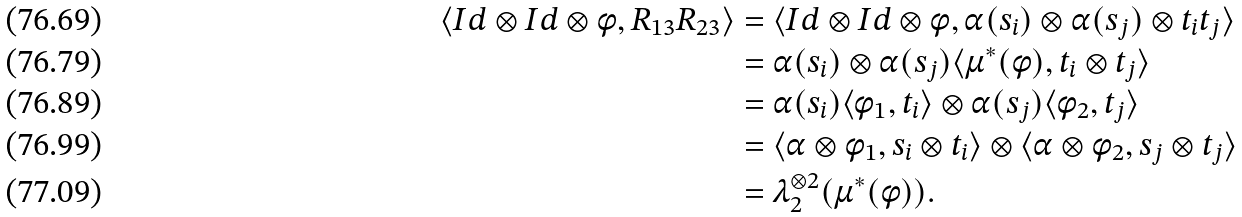<formula> <loc_0><loc_0><loc_500><loc_500>\langle I d \otimes I d \otimes \phi , R _ { 1 3 } R _ { 2 3 } \rangle & = \langle I d \otimes I d \otimes \phi , \alpha ( s _ { i } ) \otimes \alpha ( s _ { j } ) \otimes t _ { i } t _ { j } \rangle \\ & = \alpha ( s _ { i } ) \otimes \alpha ( s _ { j } ) \langle \mu ^ { * } ( \phi ) , t _ { i } \otimes t _ { j } \rangle \\ & = \alpha ( s _ { i } ) \langle \phi _ { 1 } , t _ { i } \rangle \otimes \alpha ( s _ { j } ) \langle \phi _ { 2 } , t _ { j } \rangle \\ & = \langle \alpha \otimes \phi _ { 1 } , s _ { i } \otimes t _ { i } \rangle \otimes \langle \alpha \otimes \phi _ { 2 } , s _ { j } \otimes t _ { j } \rangle \\ & = \lambda _ { 2 } ^ { \otimes 2 } ( \mu ^ { * } ( \phi ) ) .</formula> 